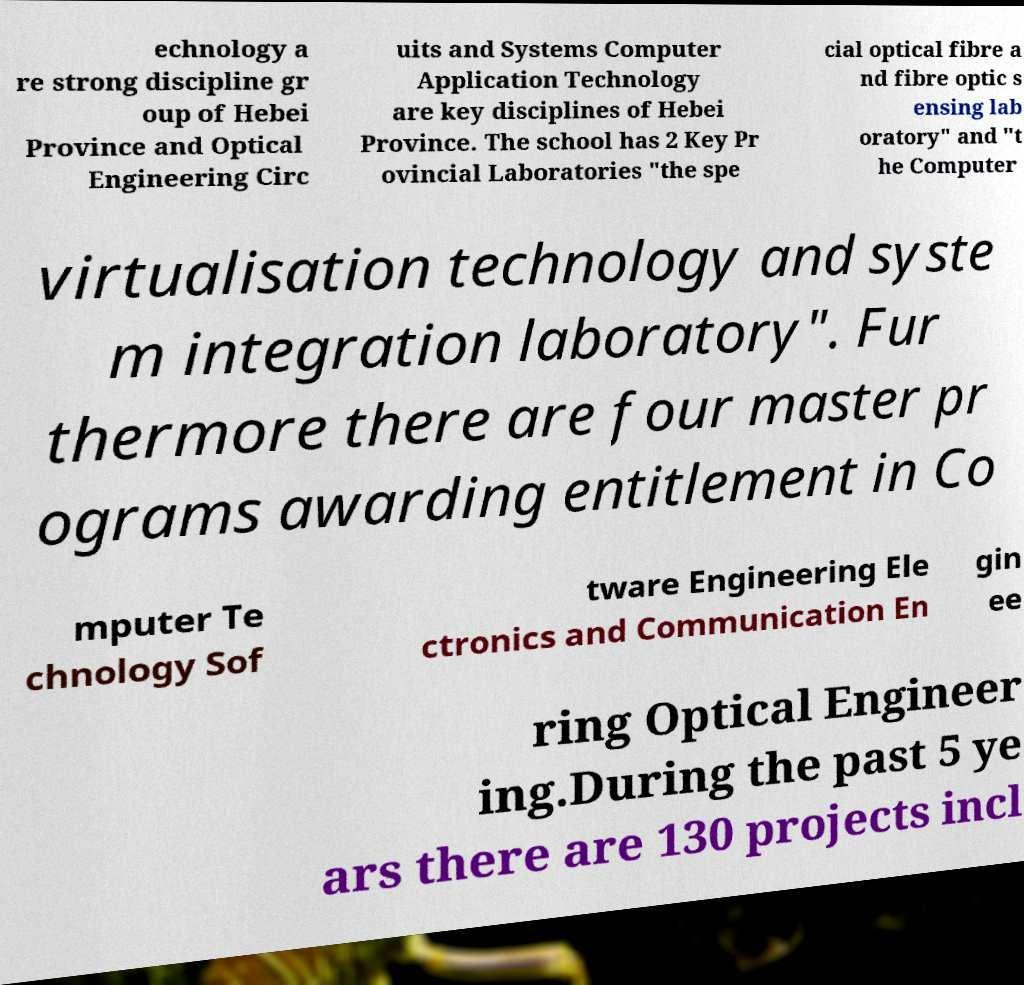Please read and relay the text visible in this image. What does it say? echnology a re strong discipline gr oup of Hebei Province and Optical Engineering Circ uits and Systems Computer Application Technology are key disciplines of Hebei Province. The school has 2 Key Pr ovincial Laboratories "the spe cial optical fibre a nd fibre optic s ensing lab oratory" and "t he Computer virtualisation technology and syste m integration laboratory". Fur thermore there are four master pr ograms awarding entitlement in Co mputer Te chnology Sof tware Engineering Ele ctronics and Communication En gin ee ring Optical Engineer ing.During the past 5 ye ars there are 130 projects incl 